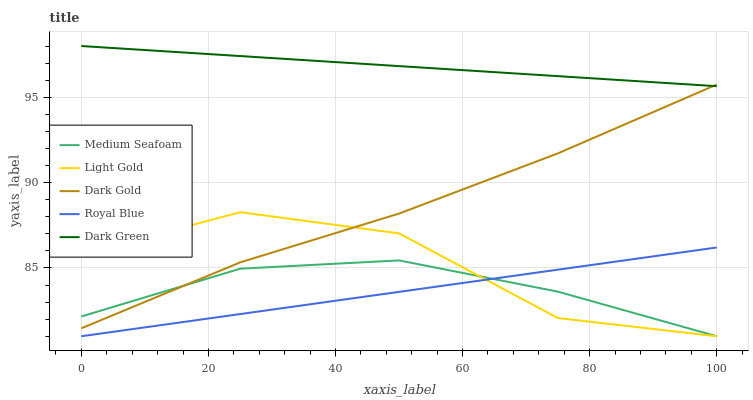Does Royal Blue have the minimum area under the curve?
Answer yes or no. Yes. Does Dark Green have the maximum area under the curve?
Answer yes or no. Yes. Does Light Gold have the minimum area under the curve?
Answer yes or no. No. Does Light Gold have the maximum area under the curve?
Answer yes or no. No. Is Royal Blue the smoothest?
Answer yes or no. Yes. Is Light Gold the roughest?
Answer yes or no. Yes. Is Light Gold the smoothest?
Answer yes or no. No. Is Dark Green the roughest?
Answer yes or no. No. Does Dark Green have the lowest value?
Answer yes or no. No. Does Dark Green have the highest value?
Answer yes or no. Yes. Does Light Gold have the highest value?
Answer yes or no. No. Is Royal Blue less than Dark Gold?
Answer yes or no. Yes. Is Dark Green greater than Royal Blue?
Answer yes or no. Yes. Does Royal Blue intersect Dark Gold?
Answer yes or no. No. 